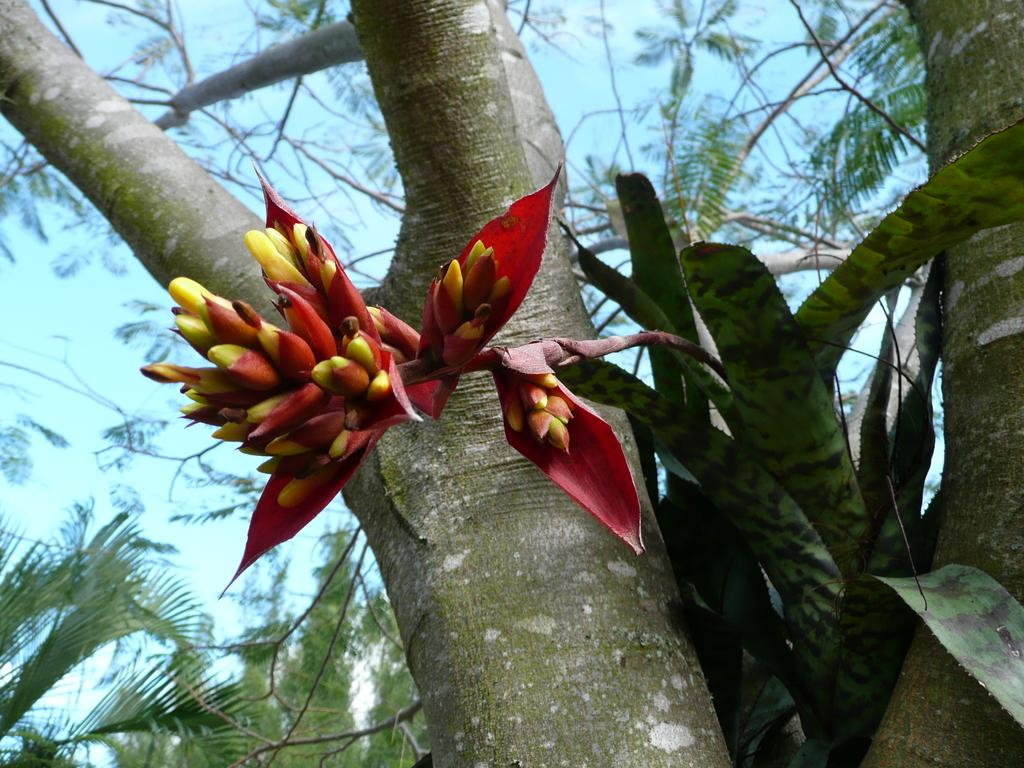What type of vegetation can be seen in the image? There is a tree and a plant in the image. What is special about the plant in the image? The plant has a flower. What colors are present in the flower? The flower is yellow and red in color. What can be seen in the sky in the image? The sky is pale blue in the image. How many wings does the tree have in the image? There are no wings present on the tree in the image. What stage of development is the plant in the image? The provided facts do not give information about the plant's development stage. 